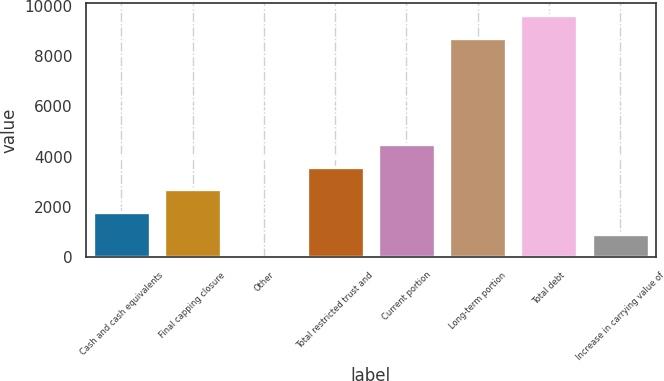Convert chart to OTSL. <chart><loc_0><loc_0><loc_500><loc_500><bar_chart><fcel>Cash and cash equivalents<fcel>Final capping closure<fcel>Other<fcel>Total restricted trust and<fcel>Current portion<fcel>Long-term portion<fcel>Total debt<fcel>Increase in carrying value of<nl><fcel>1805<fcel>2702<fcel>11<fcel>3599<fcel>4496<fcel>8728<fcel>9625<fcel>908<nl></chart> 